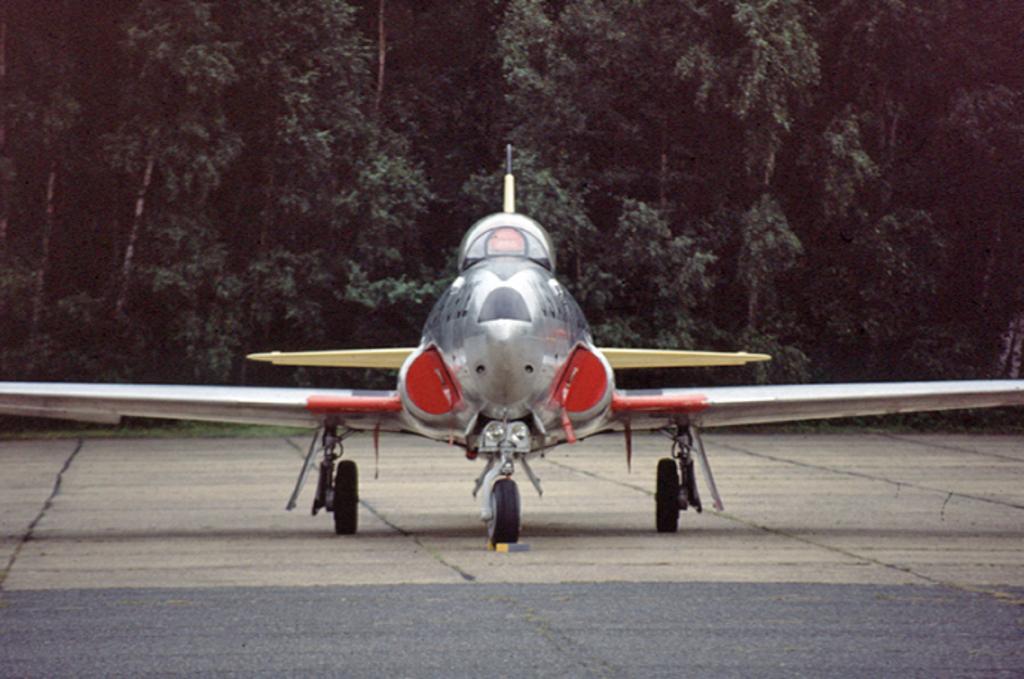Can you describe this image briefly? In this image we can see an aircraft on the road. In the background, we can see trees. 